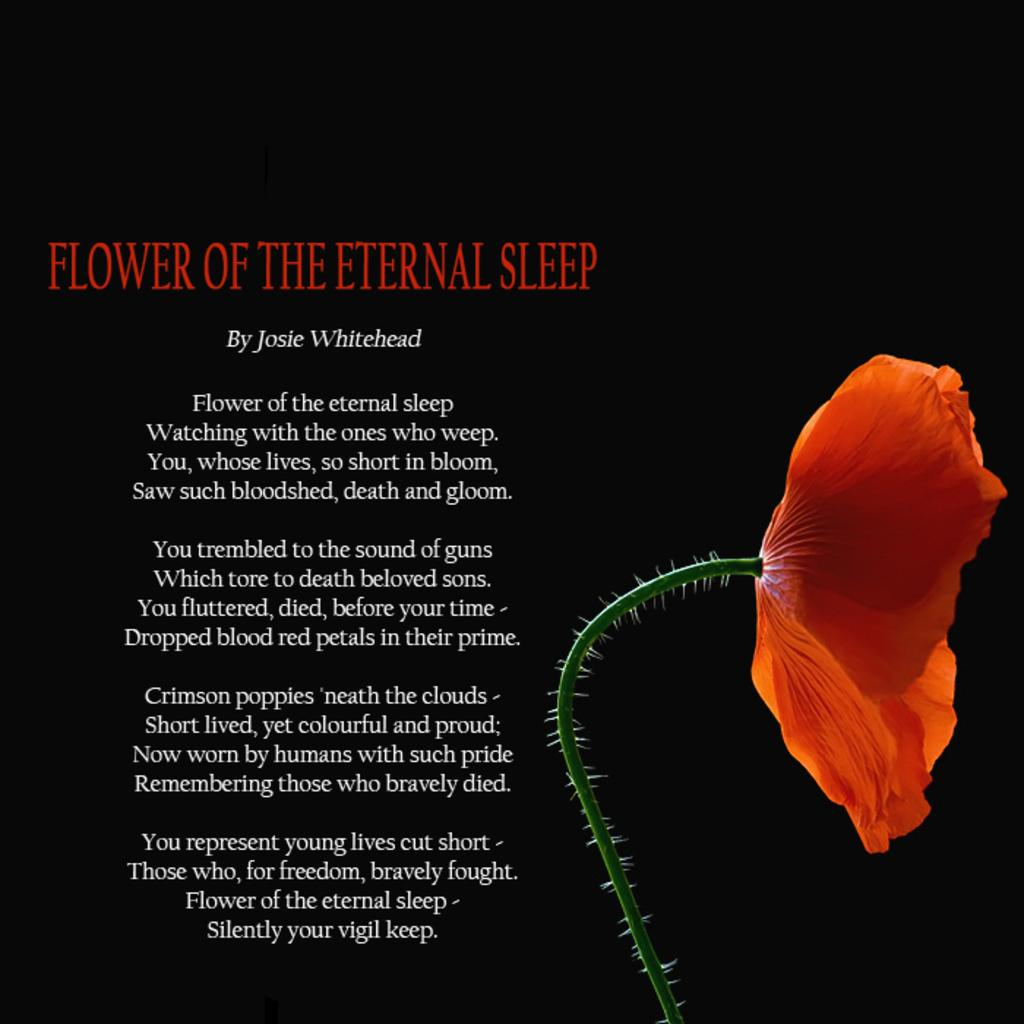What type of flower is in the image? There is an orange flower in the image. What else can be seen in the image besides the flower? There is text in the image. How would you describe the overall appearance of the image? The background of the image is dark. What type of pump is being used by the flower in the image? The flower does not use a pump, as it is a natural object and not a machine or device. 